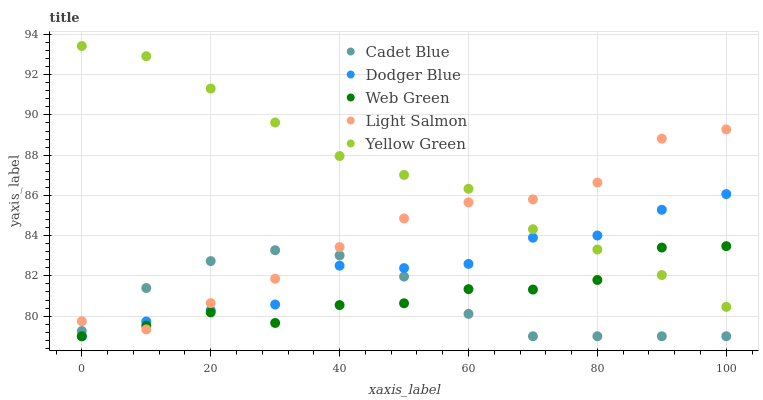Does Cadet Blue have the minimum area under the curve?
Answer yes or no. Yes. Does Yellow Green have the maximum area under the curve?
Answer yes or no. Yes. Does Dodger Blue have the minimum area under the curve?
Answer yes or no. No. Does Dodger Blue have the maximum area under the curve?
Answer yes or no. No. Is Yellow Green the smoothest?
Answer yes or no. Yes. Is Dodger Blue the roughest?
Answer yes or no. Yes. Is Cadet Blue the smoothest?
Answer yes or no. No. Is Cadet Blue the roughest?
Answer yes or no. No. Does Cadet Blue have the lowest value?
Answer yes or no. Yes. Does Yellow Green have the lowest value?
Answer yes or no. No. Does Yellow Green have the highest value?
Answer yes or no. Yes. Does Dodger Blue have the highest value?
Answer yes or no. No. Is Cadet Blue less than Yellow Green?
Answer yes or no. Yes. Is Yellow Green greater than Cadet Blue?
Answer yes or no. Yes. Does Web Green intersect Yellow Green?
Answer yes or no. Yes. Is Web Green less than Yellow Green?
Answer yes or no. No. Is Web Green greater than Yellow Green?
Answer yes or no. No. Does Cadet Blue intersect Yellow Green?
Answer yes or no. No. 